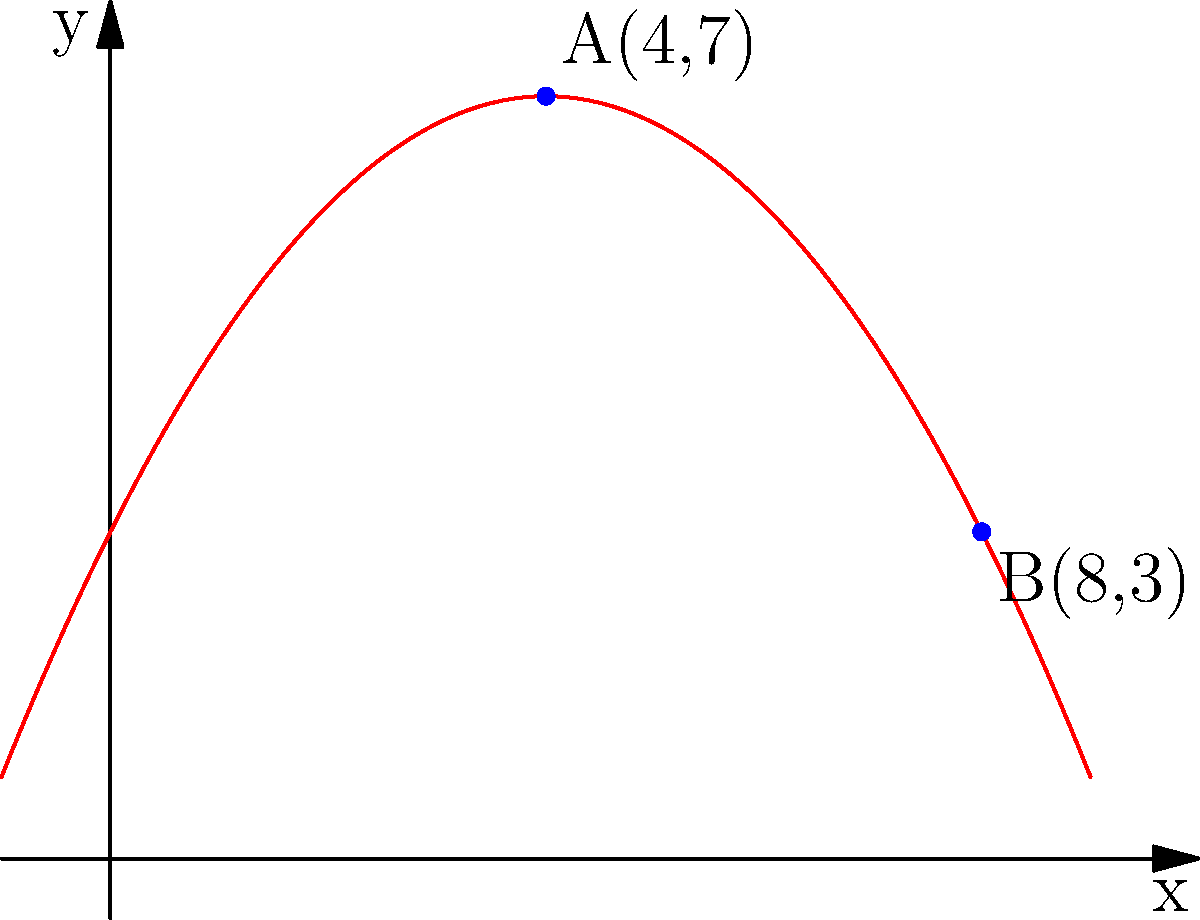In a scene depicting a graceful aerial stunt, the trajectory of a performer is modeled by the parabolic function $f(x) = -0.25x^2 + 2x + 3$, where $x$ represents the horizontal distance in meters and $f(x)$ represents the height in meters. The performer starts at point A(4,7) and ends at point B(8,3). What is the average rate of change of the performer's height with respect to the horizontal distance between points A and B? To find the average rate of change between two points, we use the formula:

$$ \text{Average Rate of Change} = \frac{\text{Change in y}}{\text{Change in x}} = \frac{y_2 - y_1}{x_2 - x_1} $$

Given:
- Point A: (4, 7)
- Point B: (8, 3)

Step 1: Calculate the change in y (vertical distance):
$\Delta y = y_2 - y_1 = 3 - 7 = -4$ meters

Step 2: Calculate the change in x (horizontal distance):
$\Delta x = x_2 - x_1 = 8 - 4 = 4$ meters

Step 3: Apply the average rate of change formula:
$$ \text{Average Rate of Change} = \frac{\Delta y}{\Delta x} = \frac{-4}{4} = -1 $$

Therefore, the average rate of change of the performer's height with respect to the horizontal distance between points A and B is -1 meter per meter.
Answer: $-1$ m/m 